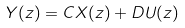<formula> <loc_0><loc_0><loc_500><loc_500>Y ( z ) = C X ( z ) + D U ( z )</formula> 